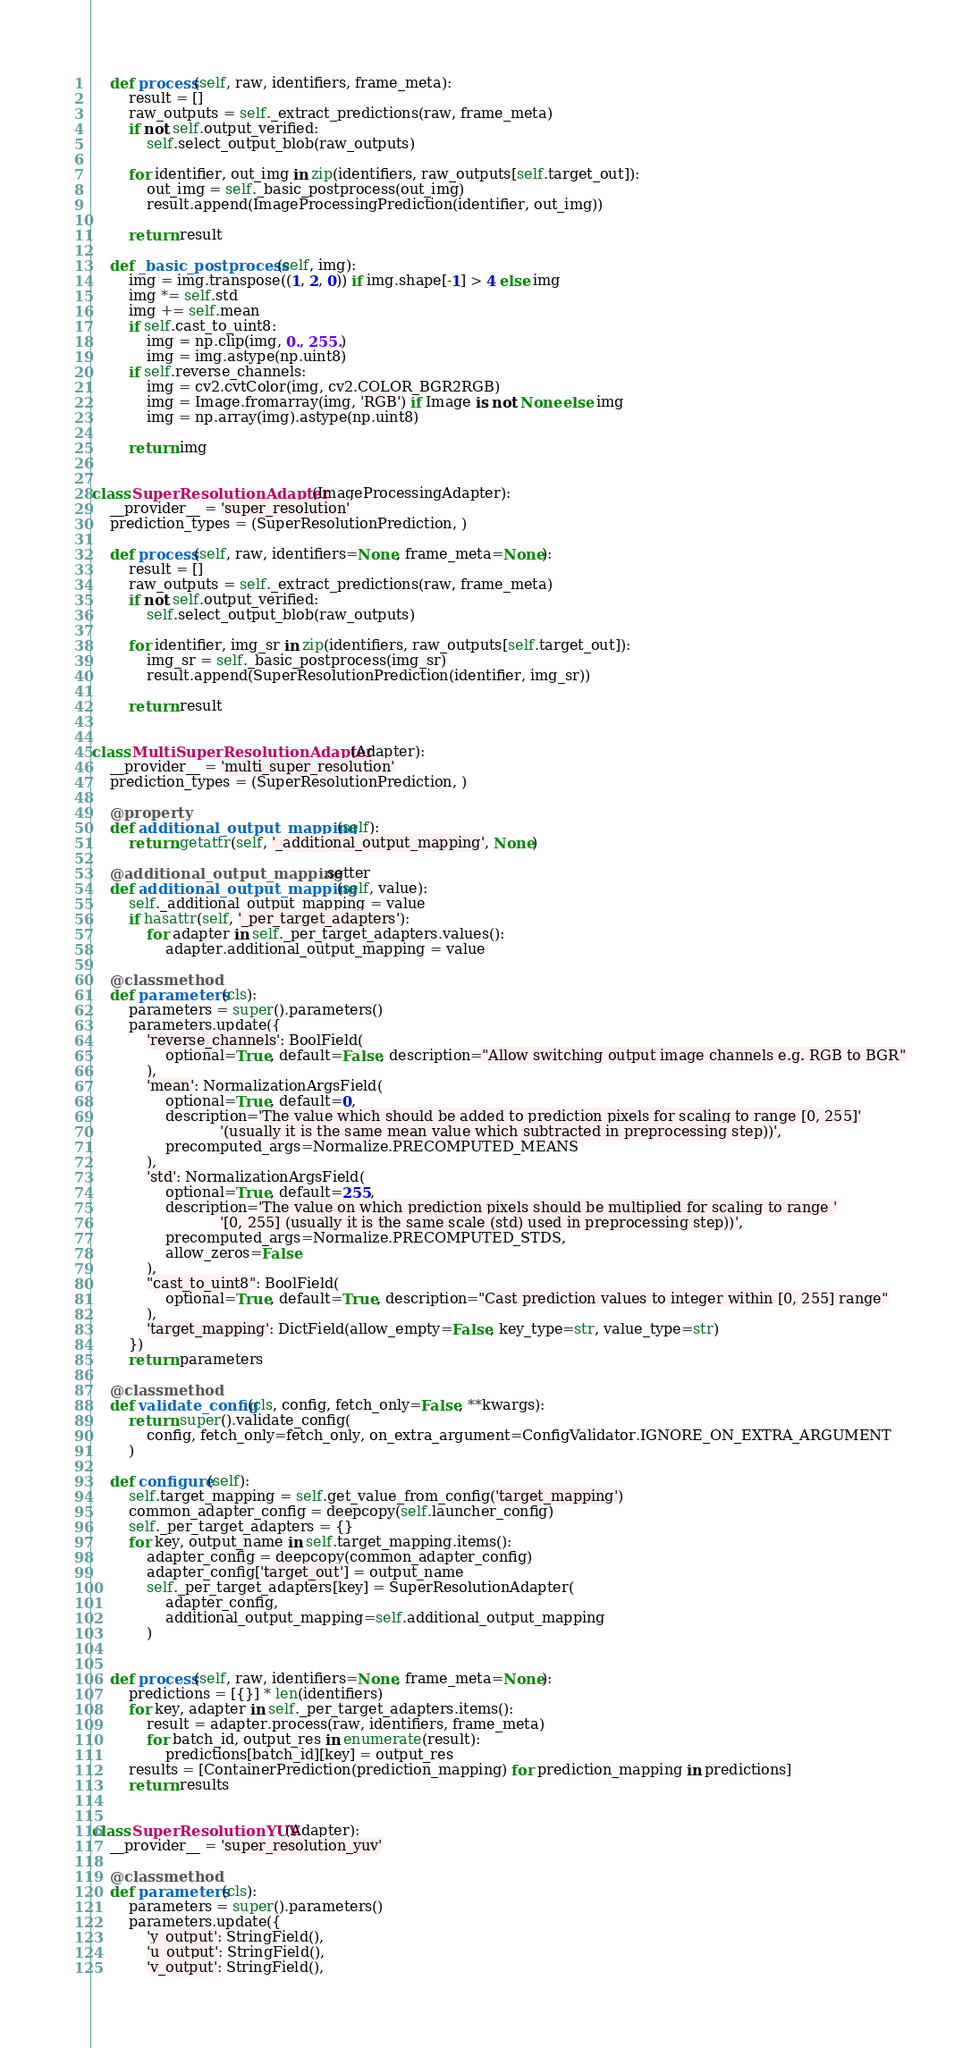Convert code to text. <code><loc_0><loc_0><loc_500><loc_500><_Python_>    def process(self, raw, identifiers, frame_meta):
        result = []
        raw_outputs = self._extract_predictions(raw, frame_meta)
        if not self.output_verified:
            self.select_output_blob(raw_outputs)

        for identifier, out_img in zip(identifiers, raw_outputs[self.target_out]):
            out_img = self._basic_postprocess(out_img)
            result.append(ImageProcessingPrediction(identifier, out_img))

        return result

    def _basic_postprocess(self, img):
        img = img.transpose((1, 2, 0)) if img.shape[-1] > 4 else img
        img *= self.std
        img += self.mean
        if self.cast_to_uint8:
            img = np.clip(img, 0., 255.)
            img = img.astype(np.uint8)
        if self.reverse_channels:
            img = cv2.cvtColor(img, cv2.COLOR_BGR2RGB)
            img = Image.fromarray(img, 'RGB') if Image is not None else img
            img = np.array(img).astype(np.uint8)

        return img


class SuperResolutionAdapter(ImageProcessingAdapter):
    __provider__ = 'super_resolution'
    prediction_types = (SuperResolutionPrediction, )

    def process(self, raw, identifiers=None, frame_meta=None):
        result = []
        raw_outputs = self._extract_predictions(raw, frame_meta)
        if not self.output_verified:
            self.select_output_blob(raw_outputs)

        for identifier, img_sr in zip(identifiers, raw_outputs[self.target_out]):
            img_sr = self._basic_postprocess(img_sr)
            result.append(SuperResolutionPrediction(identifier, img_sr))

        return result


class MultiSuperResolutionAdapter(Adapter):
    __provider__ = 'multi_super_resolution'
    prediction_types = (SuperResolutionPrediction, )

    @property
    def additional_output_mapping(self):
        return getattr(self, '_additional_output_mapping', None)

    @additional_output_mapping.setter
    def additional_output_mapping(self, value):
        self._additional_output_mapping = value
        if hasattr(self, '_per_target_adapters'):
            for adapter in self._per_target_adapters.values():
                adapter.additional_output_mapping = value

    @classmethod
    def parameters(cls):
        parameters = super().parameters()
        parameters.update({
            'reverse_channels': BoolField(
                optional=True, default=False, description="Allow switching output image channels e.g. RGB to BGR"
            ),
            'mean': NormalizationArgsField(
                optional=True, default=0,
                description='The value which should be added to prediction pixels for scaling to range [0, 255]'
                            '(usually it is the same mean value which subtracted in preprocessing step))',
                precomputed_args=Normalize.PRECOMPUTED_MEANS
            ),
            'std': NormalizationArgsField(
                optional=True, default=255,
                description='The value on which prediction pixels should be multiplied for scaling to range '
                            '[0, 255] (usually it is the same scale (std) used in preprocessing step))',
                precomputed_args=Normalize.PRECOMPUTED_STDS,
                allow_zeros=False
            ),
            "cast_to_uint8": BoolField(
                optional=True, default=True, description="Cast prediction values to integer within [0, 255] range"
            ),
            'target_mapping': DictField(allow_empty=False, key_type=str, value_type=str)
        })
        return parameters

    @classmethod
    def validate_config(cls, config, fetch_only=False, **kwargs):
        return super().validate_config(
            config, fetch_only=fetch_only, on_extra_argument=ConfigValidator.IGNORE_ON_EXTRA_ARGUMENT
        )

    def configure(self):
        self.target_mapping = self.get_value_from_config('target_mapping')
        common_adapter_config = deepcopy(self.launcher_config)
        self._per_target_adapters = {}
        for key, output_name in self.target_mapping.items():
            adapter_config = deepcopy(common_adapter_config)
            adapter_config['target_out'] = output_name
            self._per_target_adapters[key] = SuperResolutionAdapter(
                adapter_config,
                additional_output_mapping=self.additional_output_mapping
            )


    def process(self, raw, identifiers=None, frame_meta=None):
        predictions = [{}] * len(identifiers)
        for key, adapter in self._per_target_adapters.items():
            result = adapter.process(raw, identifiers, frame_meta)
            for batch_id, output_res in enumerate(result):
                predictions[batch_id][key] = output_res
        results = [ContainerPrediction(prediction_mapping) for prediction_mapping in predictions]
        return results


class SuperResolutionYUV(Adapter):
    __provider__ = 'super_resolution_yuv'

    @classmethod
    def parameters(cls):
        parameters = super().parameters()
        parameters.update({
            'y_output': StringField(),
            'u_output': StringField(),
            'v_output': StringField(),</code> 